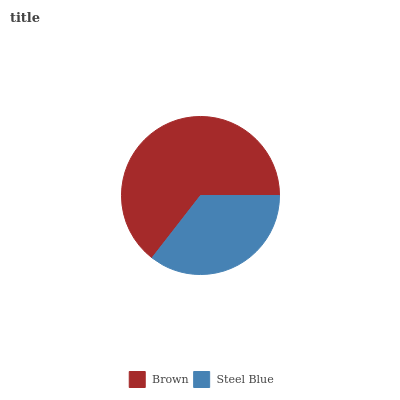Is Steel Blue the minimum?
Answer yes or no. Yes. Is Brown the maximum?
Answer yes or no. Yes. Is Steel Blue the maximum?
Answer yes or no. No. Is Brown greater than Steel Blue?
Answer yes or no. Yes. Is Steel Blue less than Brown?
Answer yes or no. Yes. Is Steel Blue greater than Brown?
Answer yes or no. No. Is Brown less than Steel Blue?
Answer yes or no. No. Is Brown the high median?
Answer yes or no. Yes. Is Steel Blue the low median?
Answer yes or no. Yes. Is Steel Blue the high median?
Answer yes or no. No. Is Brown the low median?
Answer yes or no. No. 